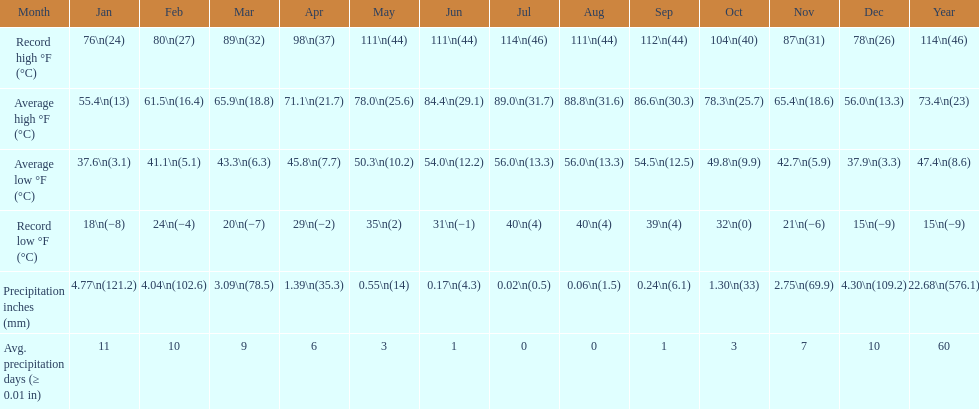How many months have experienced a record low temperature of below 25 degrees? 6. 